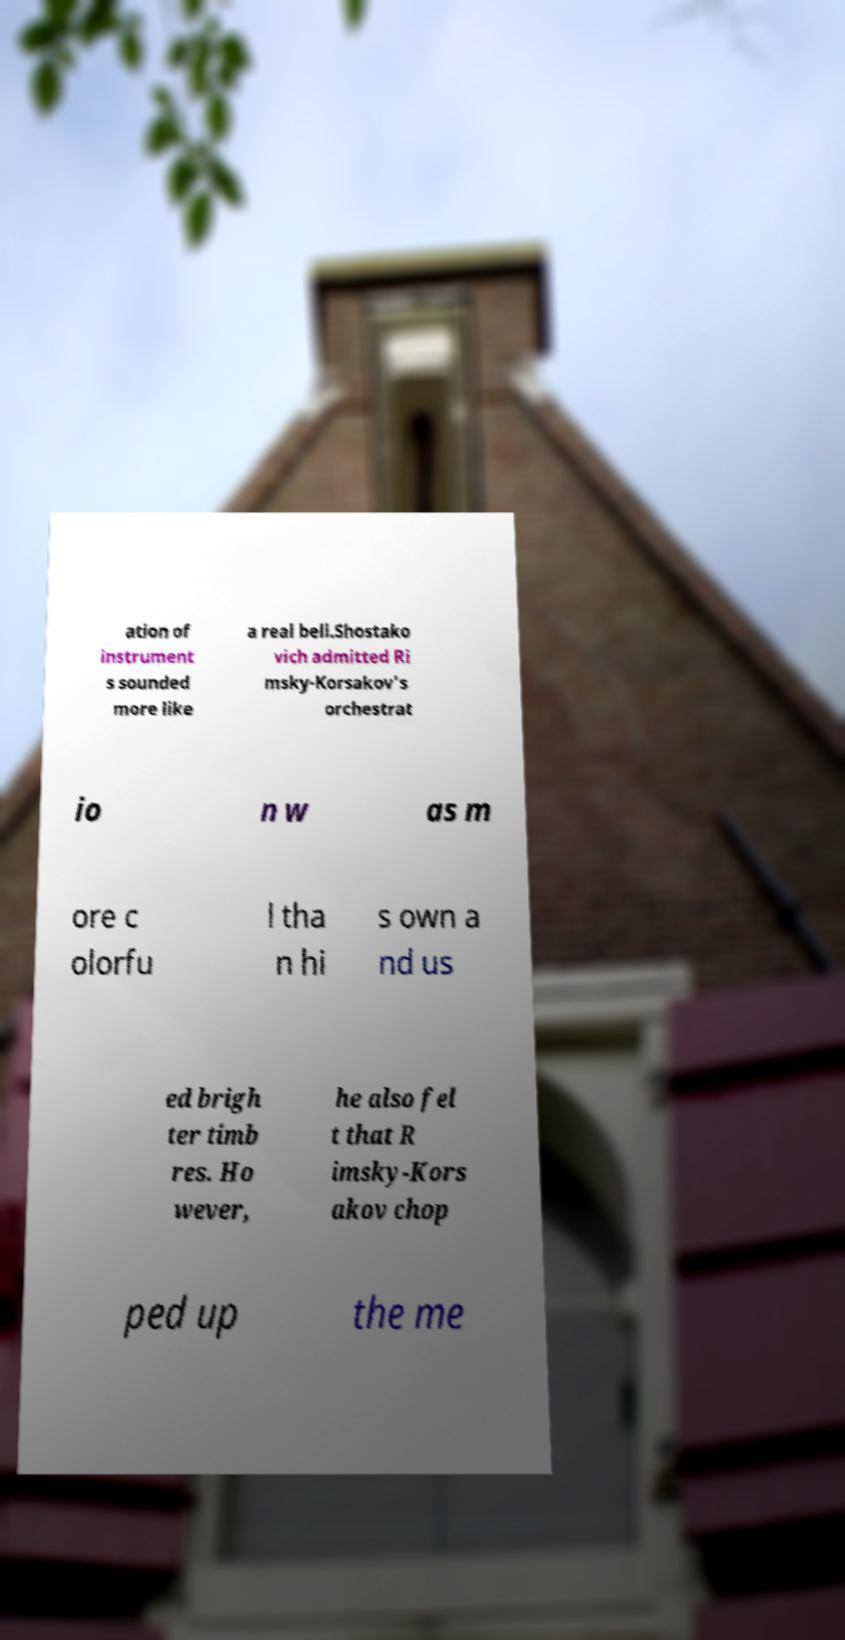Can you accurately transcribe the text from the provided image for me? ation of instrument s sounded more like a real bell.Shostako vich admitted Ri msky-Korsakov's orchestrat io n w as m ore c olorfu l tha n hi s own a nd us ed brigh ter timb res. Ho wever, he also fel t that R imsky-Kors akov chop ped up the me 